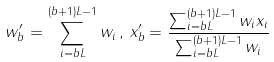Convert formula to latex. <formula><loc_0><loc_0><loc_500><loc_500>w ^ { \prime } _ { b } = \sum _ { i = b L } ^ { ( b + 1 ) L - 1 } w _ { i } \, , \, x ^ { \prime } _ { b } = \frac { \sum _ { i = b L } ^ { ( b + 1 ) L - 1 } w _ { i } x _ { i } } { \sum _ { i = b L } ^ { ( b + 1 ) L - 1 } w _ { i } }</formula> 